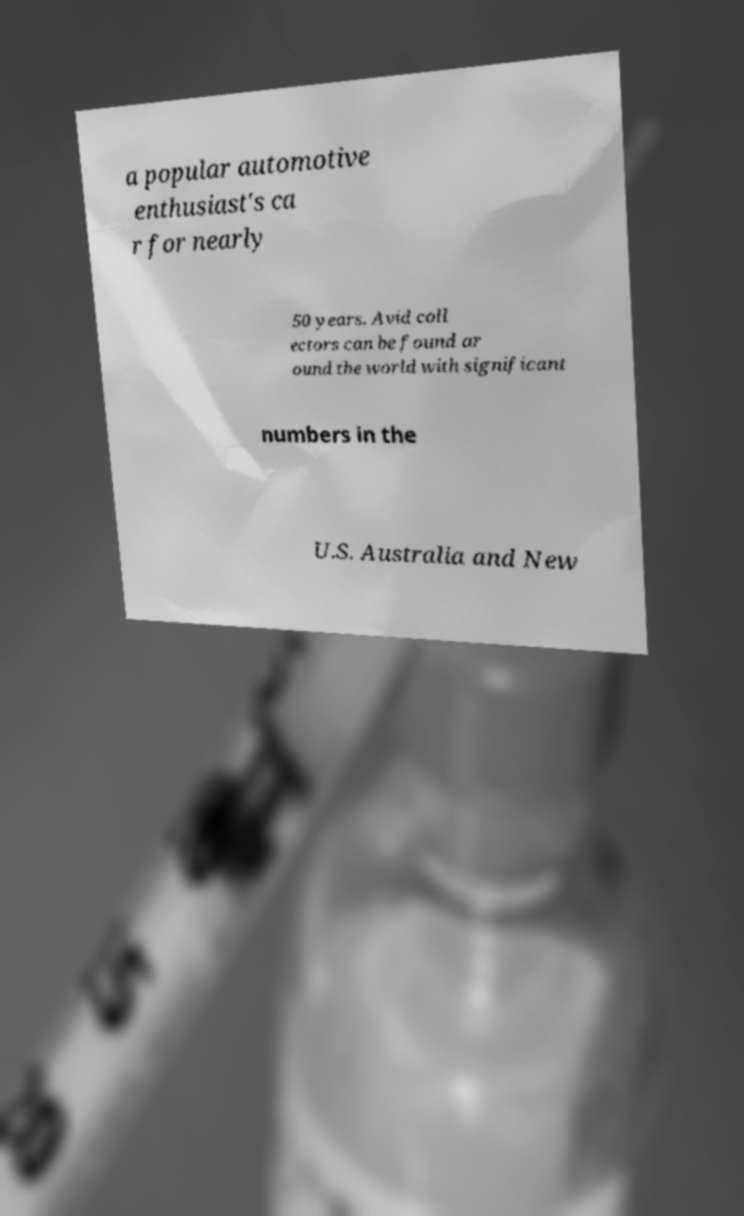What messages or text are displayed in this image? I need them in a readable, typed format. a popular automotive enthusiast's ca r for nearly 50 years. Avid coll ectors can be found ar ound the world with significant numbers in the U.S. Australia and New 